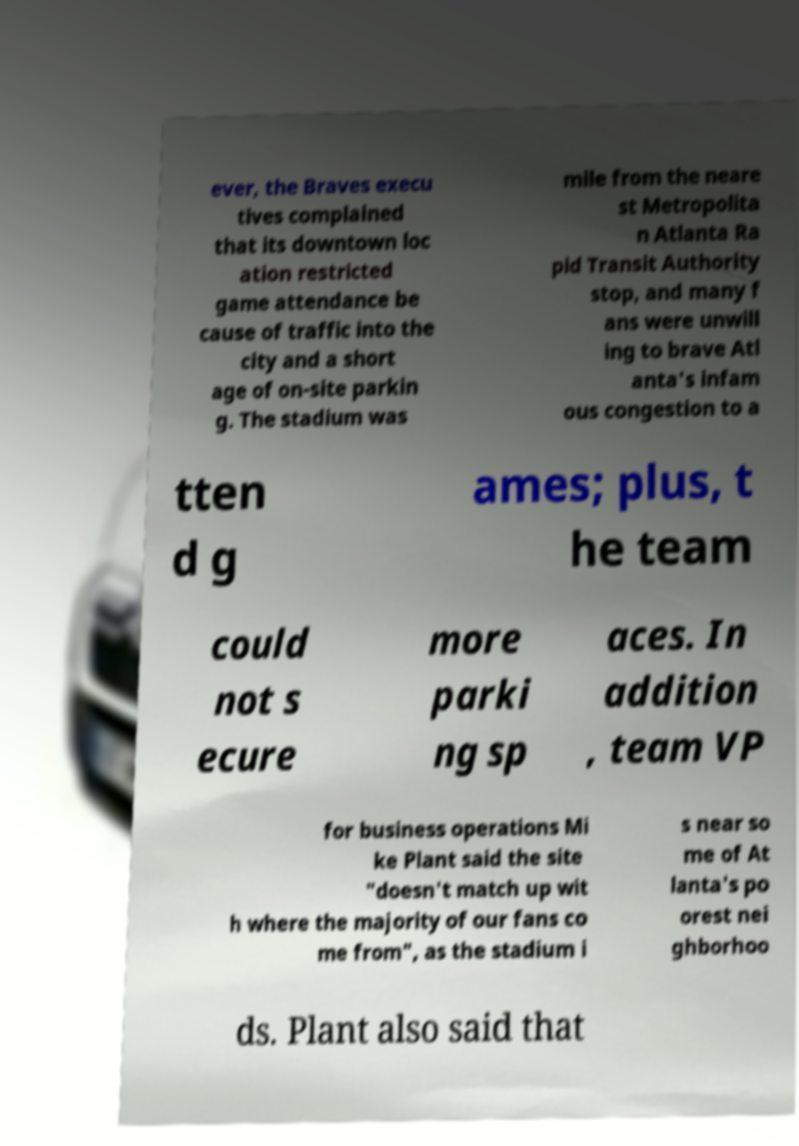There's text embedded in this image that I need extracted. Can you transcribe it verbatim? ever, the Braves execu tives complained that its downtown loc ation restricted game attendance be cause of traffic into the city and a short age of on-site parkin g. The stadium was mile from the neare st Metropolita n Atlanta Ra pid Transit Authority stop, and many f ans were unwill ing to brave Atl anta's infam ous congestion to a tten d g ames; plus, t he team could not s ecure more parki ng sp aces. In addition , team VP for business operations Mi ke Plant said the site "doesn't match up wit h where the majority of our fans co me from", as the stadium i s near so me of At lanta's po orest nei ghborhoo ds. Plant also said that 